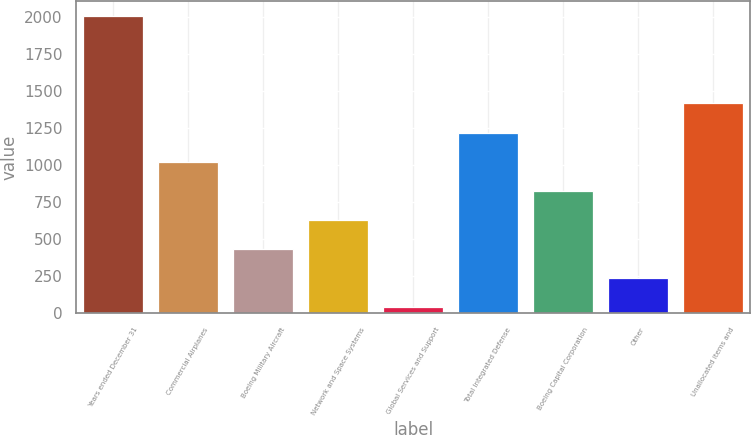Convert chart to OTSL. <chart><loc_0><loc_0><loc_500><loc_500><bar_chart><fcel>Years ended December 31<fcel>Commercial Airplanes<fcel>Boeing Military Aircraft<fcel>Network and Space Systems<fcel>Global Services and Support<fcel>Total Integrated Defense<fcel>Boeing Capital Corporation<fcel>Other<fcel>Unallocated items and<nl><fcel>2006<fcel>1022<fcel>431.6<fcel>628.4<fcel>38<fcel>1218.8<fcel>825.2<fcel>234.8<fcel>1415.6<nl></chart> 